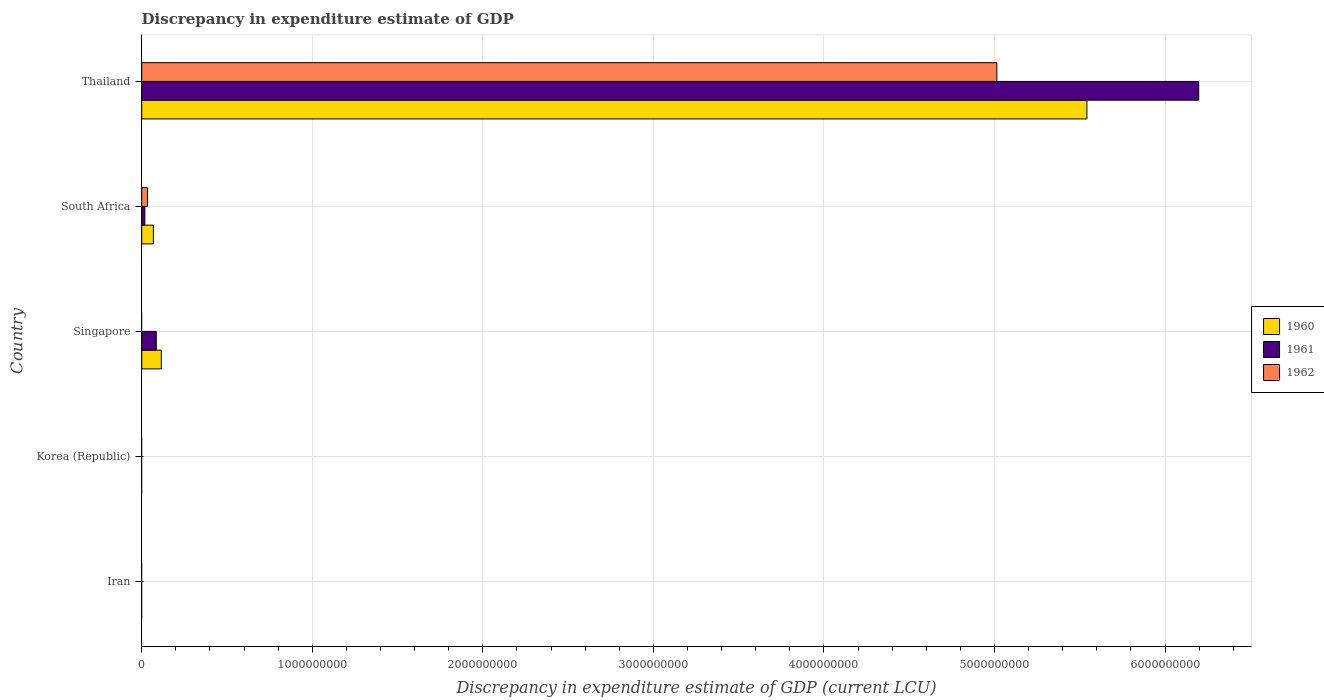Are the number of bars per tick equal to the number of legend labels?
Offer a very short reply. No. How many bars are there on the 4th tick from the top?
Provide a succinct answer. 0. How many bars are there on the 4th tick from the bottom?
Ensure brevity in your answer.  3. What is the label of the 1st group of bars from the top?
Offer a terse response. Thailand. What is the discrepancy in expenditure estimate of GDP in 1960 in South Africa?
Your response must be concise. 6.83e+07. Across all countries, what is the maximum discrepancy in expenditure estimate of GDP in 1960?
Give a very brief answer. 5.54e+09. In which country was the discrepancy in expenditure estimate of GDP in 1960 maximum?
Offer a terse response. Thailand. What is the total discrepancy in expenditure estimate of GDP in 1960 in the graph?
Offer a very short reply. 5.72e+09. What is the difference between the discrepancy in expenditure estimate of GDP in 1961 in Singapore and that in South Africa?
Your answer should be compact. 6.69e+07. What is the difference between the discrepancy in expenditure estimate of GDP in 1961 in Singapore and the discrepancy in expenditure estimate of GDP in 1960 in Korea (Republic)?
Your answer should be compact. 8.53e+07. What is the average discrepancy in expenditure estimate of GDP in 1962 per country?
Offer a terse response. 1.01e+09. What is the difference between the discrepancy in expenditure estimate of GDP in 1961 and discrepancy in expenditure estimate of GDP in 1962 in Thailand?
Your answer should be compact. 1.18e+09. What is the difference between the highest and the second highest discrepancy in expenditure estimate of GDP in 1960?
Your response must be concise. 5.43e+09. What is the difference between the highest and the lowest discrepancy in expenditure estimate of GDP in 1961?
Offer a very short reply. 6.20e+09. In how many countries, is the discrepancy in expenditure estimate of GDP in 1962 greater than the average discrepancy in expenditure estimate of GDP in 1962 taken over all countries?
Keep it short and to the point. 1. Is the sum of the discrepancy in expenditure estimate of GDP in 1961 in South Africa and Thailand greater than the maximum discrepancy in expenditure estimate of GDP in 1962 across all countries?
Your answer should be compact. Yes. How many bars are there?
Your response must be concise. 8. Are all the bars in the graph horizontal?
Offer a terse response. Yes. What is the difference between two consecutive major ticks on the X-axis?
Your answer should be very brief. 1.00e+09. Where does the legend appear in the graph?
Ensure brevity in your answer.  Center right. What is the title of the graph?
Keep it short and to the point. Discrepancy in expenditure estimate of GDP. Does "1993" appear as one of the legend labels in the graph?
Provide a short and direct response. No. What is the label or title of the X-axis?
Give a very brief answer. Discrepancy in expenditure estimate of GDP (current LCU). What is the Discrepancy in expenditure estimate of GDP (current LCU) in 1961 in Iran?
Give a very brief answer. 0. What is the Discrepancy in expenditure estimate of GDP (current LCU) in 1960 in Singapore?
Offer a terse response. 1.15e+08. What is the Discrepancy in expenditure estimate of GDP (current LCU) in 1961 in Singapore?
Your answer should be very brief. 8.53e+07. What is the Discrepancy in expenditure estimate of GDP (current LCU) in 1960 in South Africa?
Your answer should be compact. 6.83e+07. What is the Discrepancy in expenditure estimate of GDP (current LCU) in 1961 in South Africa?
Make the answer very short. 1.84e+07. What is the Discrepancy in expenditure estimate of GDP (current LCU) in 1962 in South Africa?
Keep it short and to the point. 3.40e+07. What is the Discrepancy in expenditure estimate of GDP (current LCU) in 1960 in Thailand?
Offer a terse response. 5.54e+09. What is the Discrepancy in expenditure estimate of GDP (current LCU) of 1961 in Thailand?
Offer a terse response. 6.20e+09. What is the Discrepancy in expenditure estimate of GDP (current LCU) of 1962 in Thailand?
Give a very brief answer. 5.01e+09. Across all countries, what is the maximum Discrepancy in expenditure estimate of GDP (current LCU) of 1960?
Make the answer very short. 5.54e+09. Across all countries, what is the maximum Discrepancy in expenditure estimate of GDP (current LCU) in 1961?
Keep it short and to the point. 6.20e+09. Across all countries, what is the maximum Discrepancy in expenditure estimate of GDP (current LCU) of 1962?
Give a very brief answer. 5.01e+09. What is the total Discrepancy in expenditure estimate of GDP (current LCU) of 1960 in the graph?
Offer a terse response. 5.72e+09. What is the total Discrepancy in expenditure estimate of GDP (current LCU) in 1961 in the graph?
Offer a terse response. 6.30e+09. What is the total Discrepancy in expenditure estimate of GDP (current LCU) in 1962 in the graph?
Your answer should be compact. 5.05e+09. What is the difference between the Discrepancy in expenditure estimate of GDP (current LCU) of 1960 in Singapore and that in South Africa?
Keep it short and to the point. 4.66e+07. What is the difference between the Discrepancy in expenditure estimate of GDP (current LCU) in 1961 in Singapore and that in South Africa?
Your answer should be compact. 6.69e+07. What is the difference between the Discrepancy in expenditure estimate of GDP (current LCU) in 1960 in Singapore and that in Thailand?
Provide a short and direct response. -5.43e+09. What is the difference between the Discrepancy in expenditure estimate of GDP (current LCU) of 1961 in Singapore and that in Thailand?
Give a very brief answer. -6.11e+09. What is the difference between the Discrepancy in expenditure estimate of GDP (current LCU) in 1960 in South Africa and that in Thailand?
Offer a terse response. -5.47e+09. What is the difference between the Discrepancy in expenditure estimate of GDP (current LCU) of 1961 in South Africa and that in Thailand?
Make the answer very short. -6.18e+09. What is the difference between the Discrepancy in expenditure estimate of GDP (current LCU) in 1962 in South Africa and that in Thailand?
Offer a terse response. -4.98e+09. What is the difference between the Discrepancy in expenditure estimate of GDP (current LCU) in 1960 in Singapore and the Discrepancy in expenditure estimate of GDP (current LCU) in 1961 in South Africa?
Your response must be concise. 9.65e+07. What is the difference between the Discrepancy in expenditure estimate of GDP (current LCU) of 1960 in Singapore and the Discrepancy in expenditure estimate of GDP (current LCU) of 1962 in South Africa?
Provide a succinct answer. 8.09e+07. What is the difference between the Discrepancy in expenditure estimate of GDP (current LCU) in 1961 in Singapore and the Discrepancy in expenditure estimate of GDP (current LCU) in 1962 in South Africa?
Your answer should be compact. 5.13e+07. What is the difference between the Discrepancy in expenditure estimate of GDP (current LCU) in 1960 in Singapore and the Discrepancy in expenditure estimate of GDP (current LCU) in 1961 in Thailand?
Your answer should be very brief. -6.08e+09. What is the difference between the Discrepancy in expenditure estimate of GDP (current LCU) of 1960 in Singapore and the Discrepancy in expenditure estimate of GDP (current LCU) of 1962 in Thailand?
Your response must be concise. -4.90e+09. What is the difference between the Discrepancy in expenditure estimate of GDP (current LCU) in 1961 in Singapore and the Discrepancy in expenditure estimate of GDP (current LCU) in 1962 in Thailand?
Ensure brevity in your answer.  -4.93e+09. What is the difference between the Discrepancy in expenditure estimate of GDP (current LCU) of 1960 in South Africa and the Discrepancy in expenditure estimate of GDP (current LCU) of 1961 in Thailand?
Offer a terse response. -6.13e+09. What is the difference between the Discrepancy in expenditure estimate of GDP (current LCU) in 1960 in South Africa and the Discrepancy in expenditure estimate of GDP (current LCU) in 1962 in Thailand?
Your response must be concise. -4.95e+09. What is the difference between the Discrepancy in expenditure estimate of GDP (current LCU) in 1961 in South Africa and the Discrepancy in expenditure estimate of GDP (current LCU) in 1962 in Thailand?
Your answer should be compact. -5.00e+09. What is the average Discrepancy in expenditure estimate of GDP (current LCU) in 1960 per country?
Give a very brief answer. 1.14e+09. What is the average Discrepancy in expenditure estimate of GDP (current LCU) in 1961 per country?
Your response must be concise. 1.26e+09. What is the average Discrepancy in expenditure estimate of GDP (current LCU) in 1962 per country?
Your answer should be compact. 1.01e+09. What is the difference between the Discrepancy in expenditure estimate of GDP (current LCU) in 1960 and Discrepancy in expenditure estimate of GDP (current LCU) in 1961 in Singapore?
Your answer should be very brief. 2.96e+07. What is the difference between the Discrepancy in expenditure estimate of GDP (current LCU) of 1960 and Discrepancy in expenditure estimate of GDP (current LCU) of 1961 in South Africa?
Your response must be concise. 4.99e+07. What is the difference between the Discrepancy in expenditure estimate of GDP (current LCU) in 1960 and Discrepancy in expenditure estimate of GDP (current LCU) in 1962 in South Africa?
Make the answer very short. 3.43e+07. What is the difference between the Discrepancy in expenditure estimate of GDP (current LCU) of 1961 and Discrepancy in expenditure estimate of GDP (current LCU) of 1962 in South Africa?
Offer a terse response. -1.56e+07. What is the difference between the Discrepancy in expenditure estimate of GDP (current LCU) in 1960 and Discrepancy in expenditure estimate of GDP (current LCU) in 1961 in Thailand?
Give a very brief answer. -6.56e+08. What is the difference between the Discrepancy in expenditure estimate of GDP (current LCU) in 1960 and Discrepancy in expenditure estimate of GDP (current LCU) in 1962 in Thailand?
Give a very brief answer. 5.28e+08. What is the difference between the Discrepancy in expenditure estimate of GDP (current LCU) of 1961 and Discrepancy in expenditure estimate of GDP (current LCU) of 1962 in Thailand?
Your answer should be very brief. 1.18e+09. What is the ratio of the Discrepancy in expenditure estimate of GDP (current LCU) of 1960 in Singapore to that in South Africa?
Your response must be concise. 1.68. What is the ratio of the Discrepancy in expenditure estimate of GDP (current LCU) of 1961 in Singapore to that in South Africa?
Your response must be concise. 4.64. What is the ratio of the Discrepancy in expenditure estimate of GDP (current LCU) of 1960 in Singapore to that in Thailand?
Provide a short and direct response. 0.02. What is the ratio of the Discrepancy in expenditure estimate of GDP (current LCU) in 1961 in Singapore to that in Thailand?
Provide a succinct answer. 0.01. What is the ratio of the Discrepancy in expenditure estimate of GDP (current LCU) of 1960 in South Africa to that in Thailand?
Your answer should be very brief. 0.01. What is the ratio of the Discrepancy in expenditure estimate of GDP (current LCU) in 1961 in South Africa to that in Thailand?
Give a very brief answer. 0. What is the ratio of the Discrepancy in expenditure estimate of GDP (current LCU) in 1962 in South Africa to that in Thailand?
Provide a short and direct response. 0.01. What is the difference between the highest and the second highest Discrepancy in expenditure estimate of GDP (current LCU) of 1960?
Ensure brevity in your answer.  5.43e+09. What is the difference between the highest and the second highest Discrepancy in expenditure estimate of GDP (current LCU) in 1961?
Your response must be concise. 6.11e+09. What is the difference between the highest and the lowest Discrepancy in expenditure estimate of GDP (current LCU) of 1960?
Your response must be concise. 5.54e+09. What is the difference between the highest and the lowest Discrepancy in expenditure estimate of GDP (current LCU) of 1961?
Provide a short and direct response. 6.20e+09. What is the difference between the highest and the lowest Discrepancy in expenditure estimate of GDP (current LCU) in 1962?
Your response must be concise. 5.01e+09. 